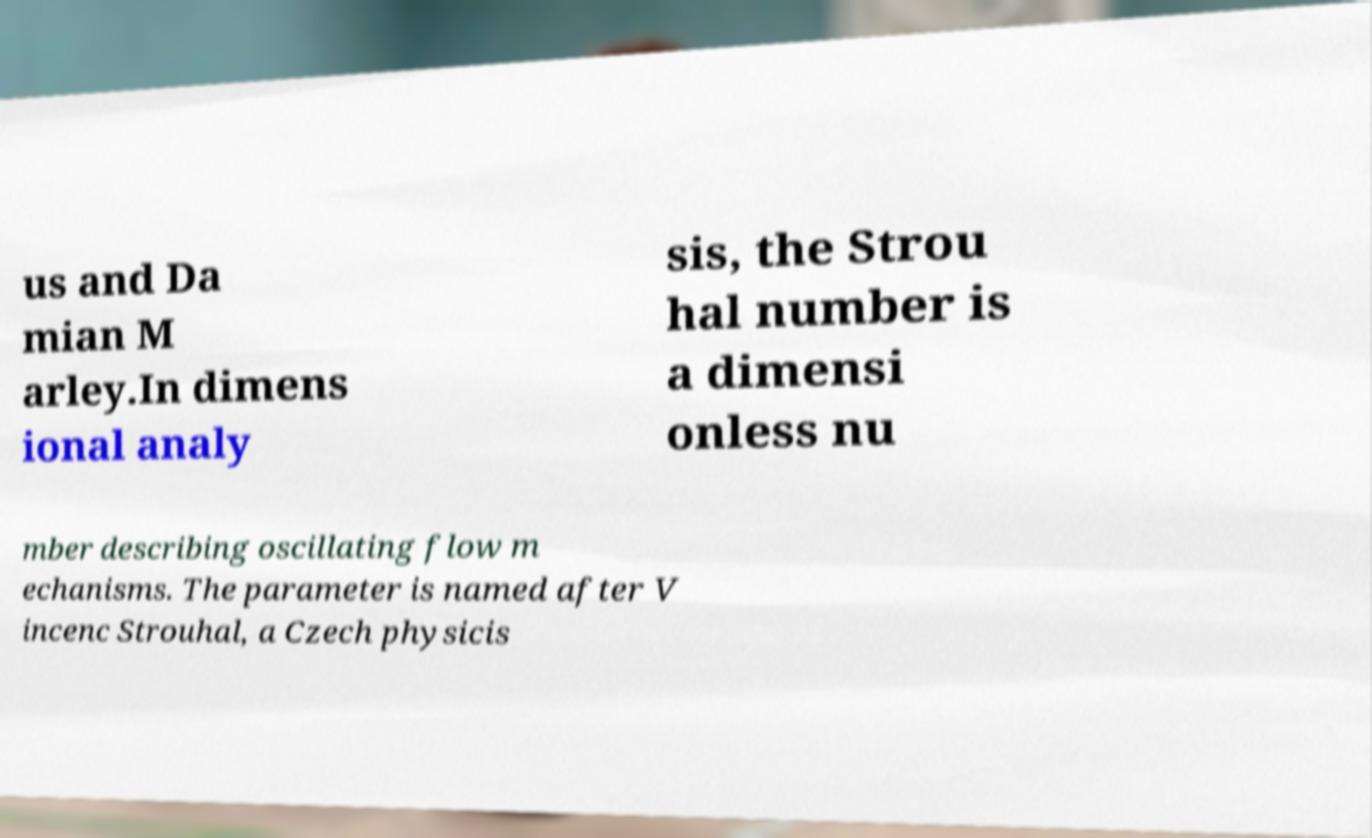There's text embedded in this image that I need extracted. Can you transcribe it verbatim? us and Da mian M arley.In dimens ional analy sis, the Strou hal number is a dimensi onless nu mber describing oscillating flow m echanisms. The parameter is named after V incenc Strouhal, a Czech physicis 